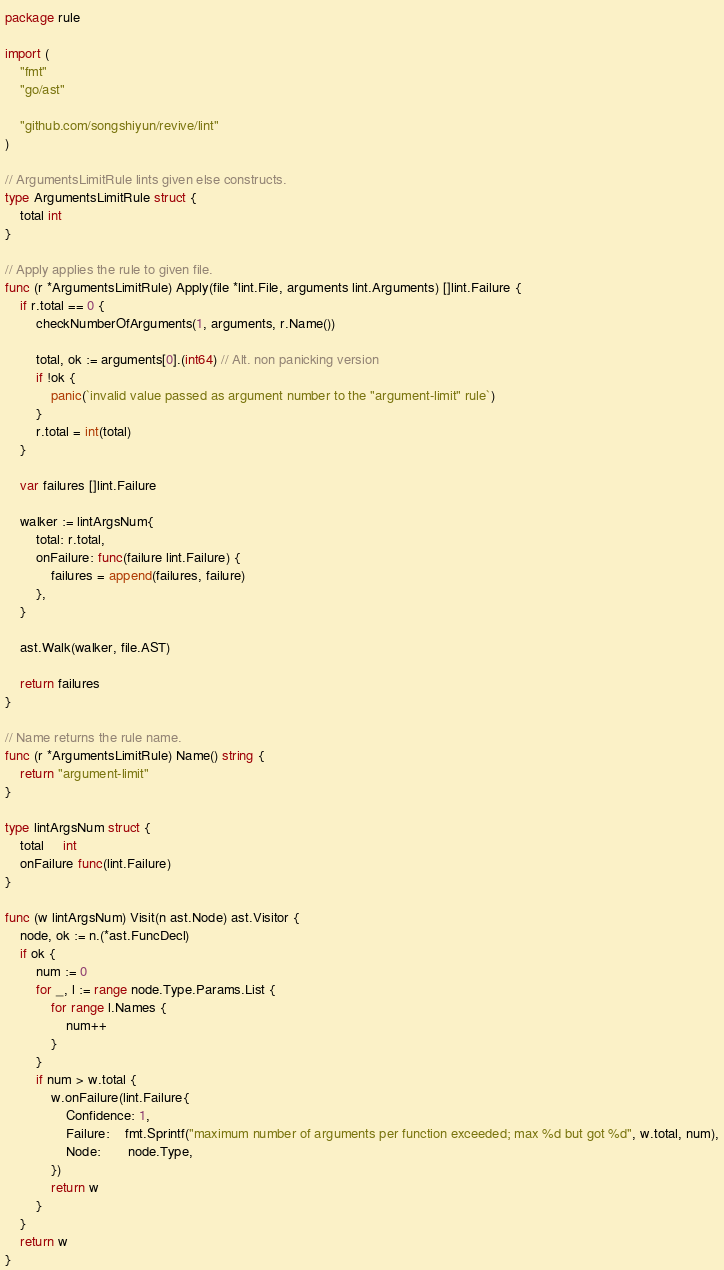Convert code to text. <code><loc_0><loc_0><loc_500><loc_500><_Go_>package rule

import (
	"fmt"
	"go/ast"

	"github.com/songshiyun/revive/lint"
)

// ArgumentsLimitRule lints given else constructs.
type ArgumentsLimitRule struct {
	total int
}

// Apply applies the rule to given file.
func (r *ArgumentsLimitRule) Apply(file *lint.File, arguments lint.Arguments) []lint.Failure {
	if r.total == 0 {
		checkNumberOfArguments(1, arguments, r.Name())

		total, ok := arguments[0].(int64) // Alt. non panicking version
		if !ok {
			panic(`invalid value passed as argument number to the "argument-limit" rule`)
		}
		r.total = int(total)
	}

	var failures []lint.Failure

	walker := lintArgsNum{
		total: r.total,
		onFailure: func(failure lint.Failure) {
			failures = append(failures, failure)
		},
	}

	ast.Walk(walker, file.AST)

	return failures
}

// Name returns the rule name.
func (r *ArgumentsLimitRule) Name() string {
	return "argument-limit"
}

type lintArgsNum struct {
	total     int
	onFailure func(lint.Failure)
}

func (w lintArgsNum) Visit(n ast.Node) ast.Visitor {
	node, ok := n.(*ast.FuncDecl)
	if ok {
		num := 0
		for _, l := range node.Type.Params.List {
			for range l.Names {
				num++
			}
		}
		if num > w.total {
			w.onFailure(lint.Failure{
				Confidence: 1,
				Failure:    fmt.Sprintf("maximum number of arguments per function exceeded; max %d but got %d", w.total, num),
				Node:       node.Type,
			})
			return w
		}
	}
	return w
}
</code> 